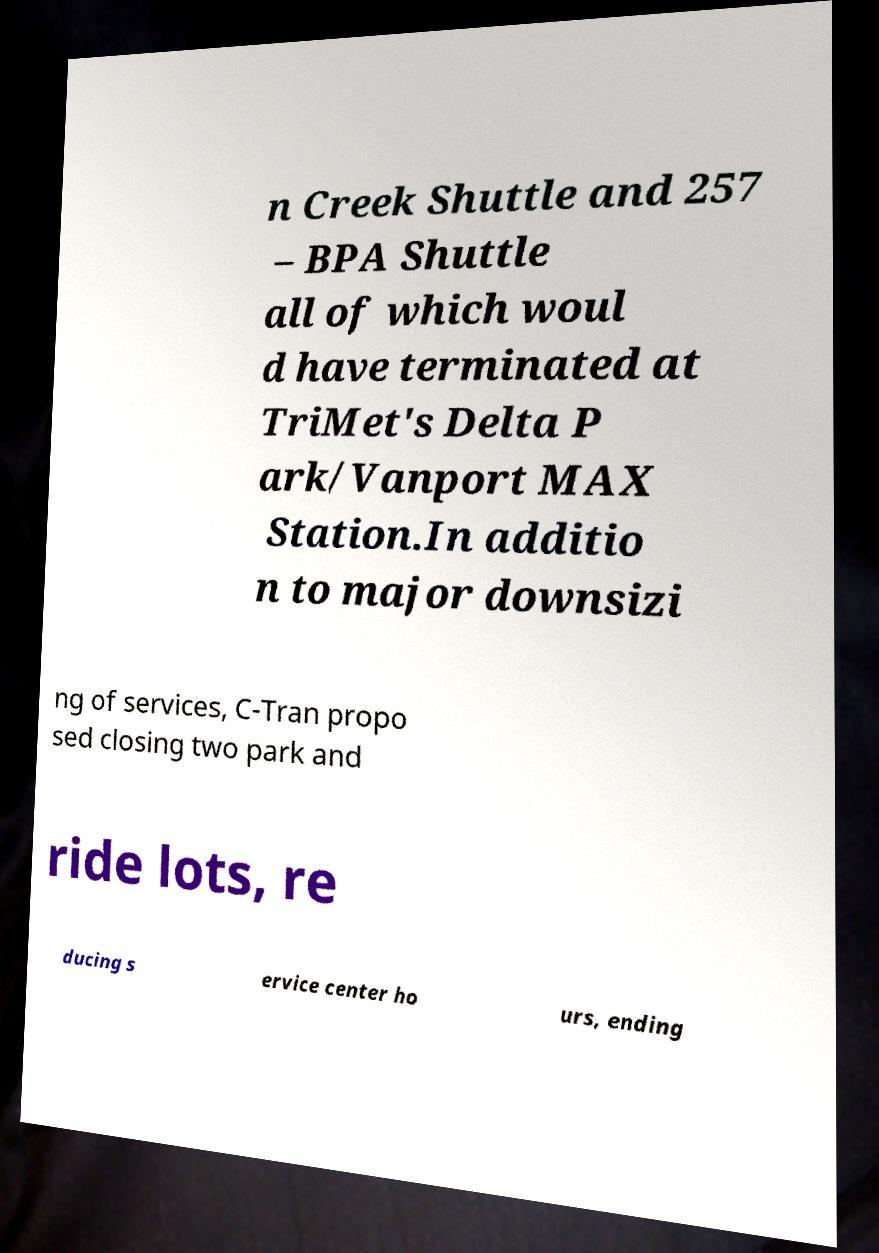Can you read and provide the text displayed in the image?This photo seems to have some interesting text. Can you extract and type it out for me? n Creek Shuttle and 257 – BPA Shuttle all of which woul d have terminated at TriMet's Delta P ark/Vanport MAX Station.In additio n to major downsizi ng of services, C-Tran propo sed closing two park and ride lots, re ducing s ervice center ho urs, ending 